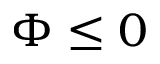Convert formula to latex. <formula><loc_0><loc_0><loc_500><loc_500>\Phi \leq 0</formula> 